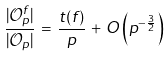Convert formula to latex. <formula><loc_0><loc_0><loc_500><loc_500>\frac { | \mathcal { O } ^ { f } _ { p } | } { | \mathcal { O } _ { p } | } \, = \, \frac { t ( f ) } { p } \, + \, O \left ( p ^ { - \frac { 3 } { 2 } } \right )</formula> 